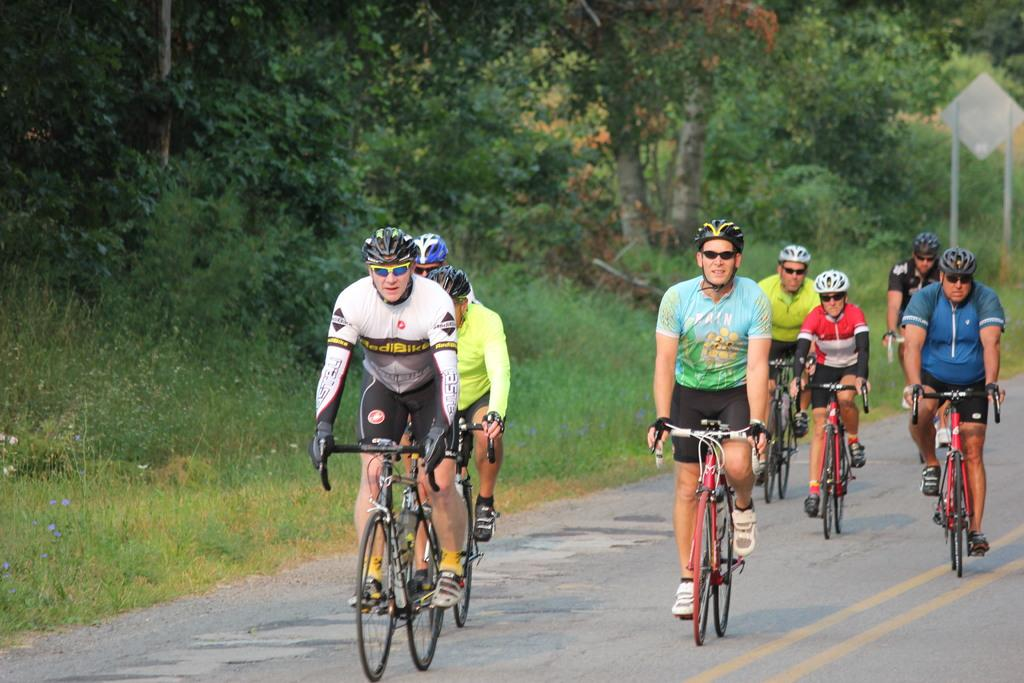What are the persons in the image doing? The persons in the image are riding on bi-cycles. What safety precaution are the persons taking while riding their bi-cycles? The persons are wearing helmets. What type of natural environment can be seen in the image? There are trees visible in the image. What man-made object can be seen in the image? There is a signboard in the image. Can you tell me which person's eye is twitching in the image? There is no indication in the image that any person's eye is twitching. Who is the owner of the bi-cycles in the image? The image does not provide information about the ownership of the bi-cycles. 